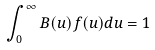Convert formula to latex. <formula><loc_0><loc_0><loc_500><loc_500>\int _ { 0 } ^ { \infty } B ( u ) f ( u ) d u = 1</formula> 